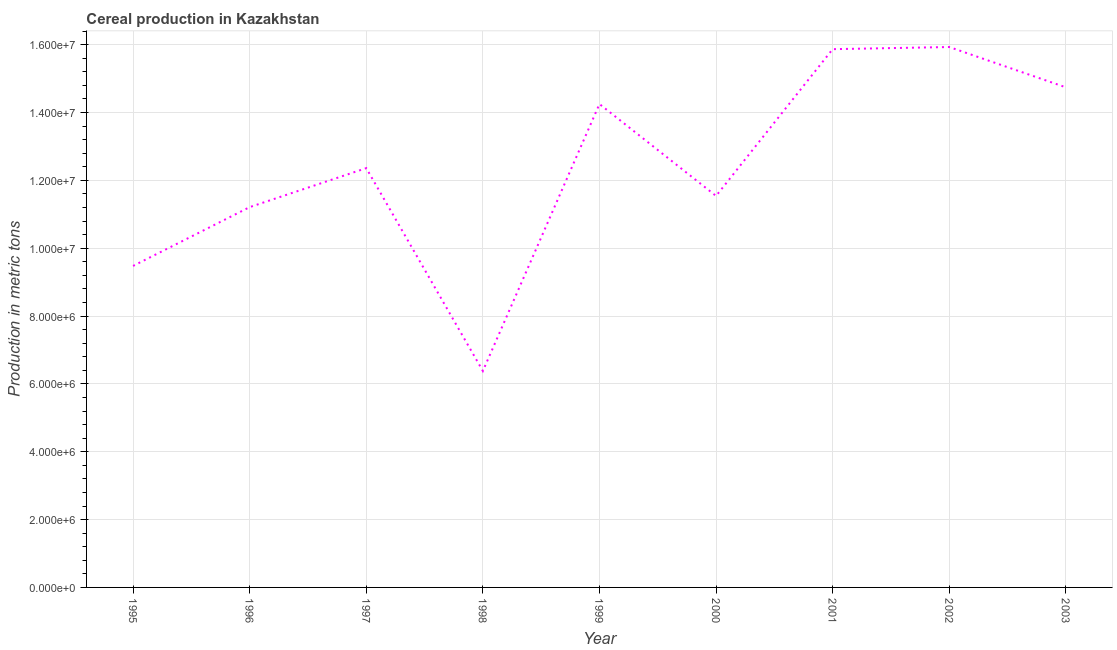What is the cereal production in 2001?
Offer a terse response. 1.59e+07. Across all years, what is the maximum cereal production?
Keep it short and to the point. 1.59e+07. Across all years, what is the minimum cereal production?
Provide a short and direct response. 6.38e+06. In which year was the cereal production minimum?
Provide a succinct answer. 1998. What is the sum of the cereal production?
Your answer should be compact. 1.12e+08. What is the difference between the cereal production in 1997 and 1999?
Give a very brief answer. -1.89e+06. What is the average cereal production per year?
Give a very brief answer. 1.24e+07. What is the median cereal production?
Keep it short and to the point. 1.24e+07. What is the ratio of the cereal production in 1996 to that in 2000?
Your answer should be compact. 0.97. What is the difference between the highest and the second highest cereal production?
Provide a short and direct response. 6.33e+04. What is the difference between the highest and the lowest cereal production?
Provide a short and direct response. 9.55e+06. How many lines are there?
Keep it short and to the point. 1. How many years are there in the graph?
Provide a succinct answer. 9. What is the difference between two consecutive major ticks on the Y-axis?
Your response must be concise. 2.00e+06. Does the graph contain any zero values?
Your response must be concise. No. Does the graph contain grids?
Your response must be concise. Yes. What is the title of the graph?
Your answer should be very brief. Cereal production in Kazakhstan. What is the label or title of the Y-axis?
Your answer should be compact. Production in metric tons. What is the Production in metric tons in 1995?
Your response must be concise. 9.48e+06. What is the Production in metric tons in 1996?
Provide a succinct answer. 1.12e+07. What is the Production in metric tons in 1997?
Ensure brevity in your answer.  1.24e+07. What is the Production in metric tons in 1998?
Your answer should be compact. 6.38e+06. What is the Production in metric tons in 1999?
Provide a short and direct response. 1.42e+07. What is the Production in metric tons in 2000?
Your answer should be compact. 1.15e+07. What is the Production in metric tons of 2001?
Provide a succinct answer. 1.59e+07. What is the Production in metric tons of 2002?
Offer a terse response. 1.59e+07. What is the Production in metric tons in 2003?
Keep it short and to the point. 1.47e+07. What is the difference between the Production in metric tons in 1995 and 1996?
Offer a very short reply. -1.73e+06. What is the difference between the Production in metric tons in 1995 and 1997?
Provide a succinct answer. -2.88e+06. What is the difference between the Production in metric tons in 1995 and 1998?
Your answer should be very brief. 3.10e+06. What is the difference between the Production in metric tons in 1995 and 1999?
Your answer should be very brief. -4.77e+06. What is the difference between the Production in metric tons in 1995 and 2000?
Your answer should be compact. -2.06e+06. What is the difference between the Production in metric tons in 1995 and 2001?
Provide a short and direct response. -6.39e+06. What is the difference between the Production in metric tons in 1995 and 2002?
Provide a succinct answer. -6.45e+06. What is the difference between the Production in metric tons in 1995 and 2003?
Make the answer very short. -5.26e+06. What is the difference between the Production in metric tons in 1996 and 1997?
Ensure brevity in your answer.  -1.15e+06. What is the difference between the Production in metric tons in 1996 and 1998?
Offer a very short reply. 4.83e+06. What is the difference between the Production in metric tons in 1996 and 1999?
Your response must be concise. -3.04e+06. What is the difference between the Production in metric tons in 1996 and 2000?
Ensure brevity in your answer.  -3.30e+05. What is the difference between the Production in metric tons in 1996 and 2001?
Your answer should be compact. -4.66e+06. What is the difference between the Production in metric tons in 1996 and 2002?
Your response must be concise. -4.72e+06. What is the difference between the Production in metric tons in 1996 and 2003?
Make the answer very short. -3.53e+06. What is the difference between the Production in metric tons in 1997 and 1998?
Give a very brief answer. 5.98e+06. What is the difference between the Production in metric tons in 1997 and 1999?
Offer a very short reply. -1.89e+06. What is the difference between the Production in metric tons in 1997 and 2000?
Your answer should be compact. 8.20e+05. What is the difference between the Production in metric tons in 1997 and 2001?
Your answer should be very brief. -3.51e+06. What is the difference between the Production in metric tons in 1997 and 2002?
Your response must be concise. -3.57e+06. What is the difference between the Production in metric tons in 1997 and 2003?
Your answer should be very brief. -2.38e+06. What is the difference between the Production in metric tons in 1998 and 1999?
Offer a very short reply. -7.87e+06. What is the difference between the Production in metric tons in 1998 and 2000?
Your answer should be very brief. -5.16e+06. What is the difference between the Production in metric tons in 1998 and 2001?
Offer a very short reply. -9.49e+06. What is the difference between the Production in metric tons in 1998 and 2002?
Provide a short and direct response. -9.55e+06. What is the difference between the Production in metric tons in 1998 and 2003?
Offer a very short reply. -8.36e+06. What is the difference between the Production in metric tons in 1999 and 2000?
Provide a short and direct response. 2.71e+06. What is the difference between the Production in metric tons in 1999 and 2001?
Make the answer very short. -1.62e+06. What is the difference between the Production in metric tons in 1999 and 2002?
Your answer should be compact. -1.68e+06. What is the difference between the Production in metric tons in 1999 and 2003?
Your response must be concise. -4.93e+05. What is the difference between the Production in metric tons in 2000 and 2001?
Keep it short and to the point. -4.33e+06. What is the difference between the Production in metric tons in 2000 and 2002?
Make the answer very short. -4.39e+06. What is the difference between the Production in metric tons in 2000 and 2003?
Provide a succinct answer. -3.20e+06. What is the difference between the Production in metric tons in 2001 and 2002?
Give a very brief answer. -6.33e+04. What is the difference between the Production in metric tons in 2001 and 2003?
Ensure brevity in your answer.  1.12e+06. What is the difference between the Production in metric tons in 2002 and 2003?
Provide a succinct answer. 1.19e+06. What is the ratio of the Production in metric tons in 1995 to that in 1996?
Ensure brevity in your answer.  0.84. What is the ratio of the Production in metric tons in 1995 to that in 1997?
Ensure brevity in your answer.  0.77. What is the ratio of the Production in metric tons in 1995 to that in 1998?
Your response must be concise. 1.49. What is the ratio of the Production in metric tons in 1995 to that in 1999?
Offer a very short reply. 0.67. What is the ratio of the Production in metric tons in 1995 to that in 2000?
Your response must be concise. 0.82. What is the ratio of the Production in metric tons in 1995 to that in 2001?
Provide a succinct answer. 0.6. What is the ratio of the Production in metric tons in 1995 to that in 2002?
Your answer should be very brief. 0.59. What is the ratio of the Production in metric tons in 1995 to that in 2003?
Make the answer very short. 0.64. What is the ratio of the Production in metric tons in 1996 to that in 1997?
Your response must be concise. 0.91. What is the ratio of the Production in metric tons in 1996 to that in 1998?
Keep it short and to the point. 1.76. What is the ratio of the Production in metric tons in 1996 to that in 1999?
Give a very brief answer. 0.79. What is the ratio of the Production in metric tons in 1996 to that in 2000?
Make the answer very short. 0.97. What is the ratio of the Production in metric tons in 1996 to that in 2001?
Offer a terse response. 0.71. What is the ratio of the Production in metric tons in 1996 to that in 2002?
Offer a very short reply. 0.7. What is the ratio of the Production in metric tons in 1996 to that in 2003?
Provide a succinct answer. 0.76. What is the ratio of the Production in metric tons in 1997 to that in 1998?
Your response must be concise. 1.94. What is the ratio of the Production in metric tons in 1997 to that in 1999?
Offer a very short reply. 0.87. What is the ratio of the Production in metric tons in 1997 to that in 2000?
Your response must be concise. 1.07. What is the ratio of the Production in metric tons in 1997 to that in 2001?
Offer a very short reply. 0.78. What is the ratio of the Production in metric tons in 1997 to that in 2002?
Provide a succinct answer. 0.78. What is the ratio of the Production in metric tons in 1997 to that in 2003?
Provide a succinct answer. 0.84. What is the ratio of the Production in metric tons in 1998 to that in 1999?
Provide a short and direct response. 0.45. What is the ratio of the Production in metric tons in 1998 to that in 2000?
Your answer should be compact. 0.55. What is the ratio of the Production in metric tons in 1998 to that in 2001?
Make the answer very short. 0.4. What is the ratio of the Production in metric tons in 1998 to that in 2002?
Provide a succinct answer. 0.4. What is the ratio of the Production in metric tons in 1998 to that in 2003?
Make the answer very short. 0.43. What is the ratio of the Production in metric tons in 1999 to that in 2000?
Provide a succinct answer. 1.24. What is the ratio of the Production in metric tons in 1999 to that in 2001?
Your response must be concise. 0.9. What is the ratio of the Production in metric tons in 1999 to that in 2002?
Provide a short and direct response. 0.89. What is the ratio of the Production in metric tons in 1999 to that in 2003?
Your answer should be very brief. 0.97. What is the ratio of the Production in metric tons in 2000 to that in 2001?
Your answer should be compact. 0.73. What is the ratio of the Production in metric tons in 2000 to that in 2002?
Ensure brevity in your answer.  0.72. What is the ratio of the Production in metric tons in 2000 to that in 2003?
Offer a terse response. 0.78. What is the ratio of the Production in metric tons in 2001 to that in 2003?
Keep it short and to the point. 1.08. What is the ratio of the Production in metric tons in 2002 to that in 2003?
Your answer should be very brief. 1.08. 